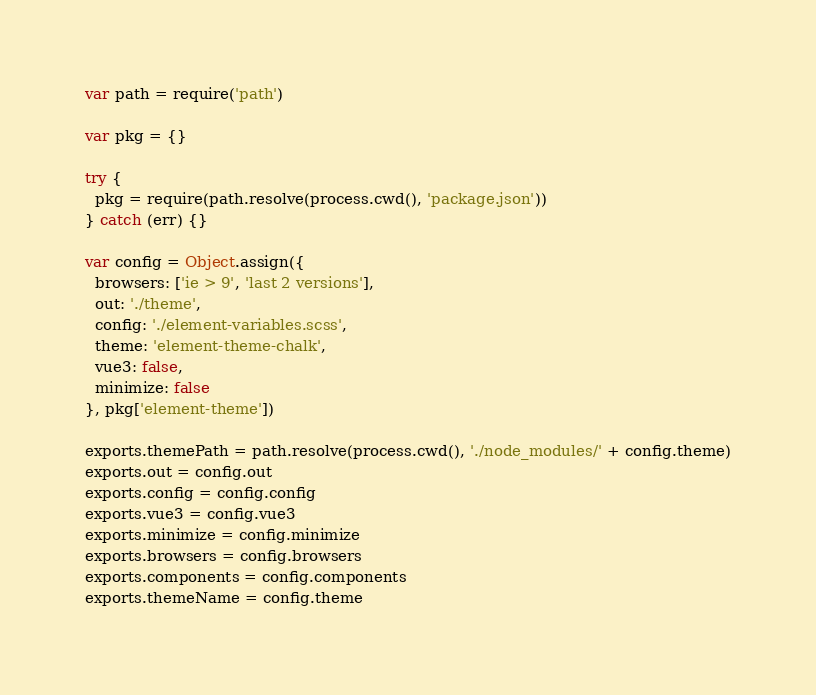Convert code to text. <code><loc_0><loc_0><loc_500><loc_500><_JavaScript_>var path = require('path')

var pkg = {}

try {
  pkg = require(path.resolve(process.cwd(), 'package.json'))
} catch (err) {}

var config = Object.assign({
  browsers: ['ie > 9', 'last 2 versions'],
  out: './theme',
  config: './element-variables.scss',
  theme: 'element-theme-chalk',
  vue3: false,
  minimize: false
}, pkg['element-theme'])

exports.themePath = path.resolve(process.cwd(), './node_modules/' + config.theme)
exports.out = config.out
exports.config = config.config
exports.vue3 = config.vue3
exports.minimize = config.minimize
exports.browsers = config.browsers
exports.components = config.components
exports.themeName = config.theme
</code> 